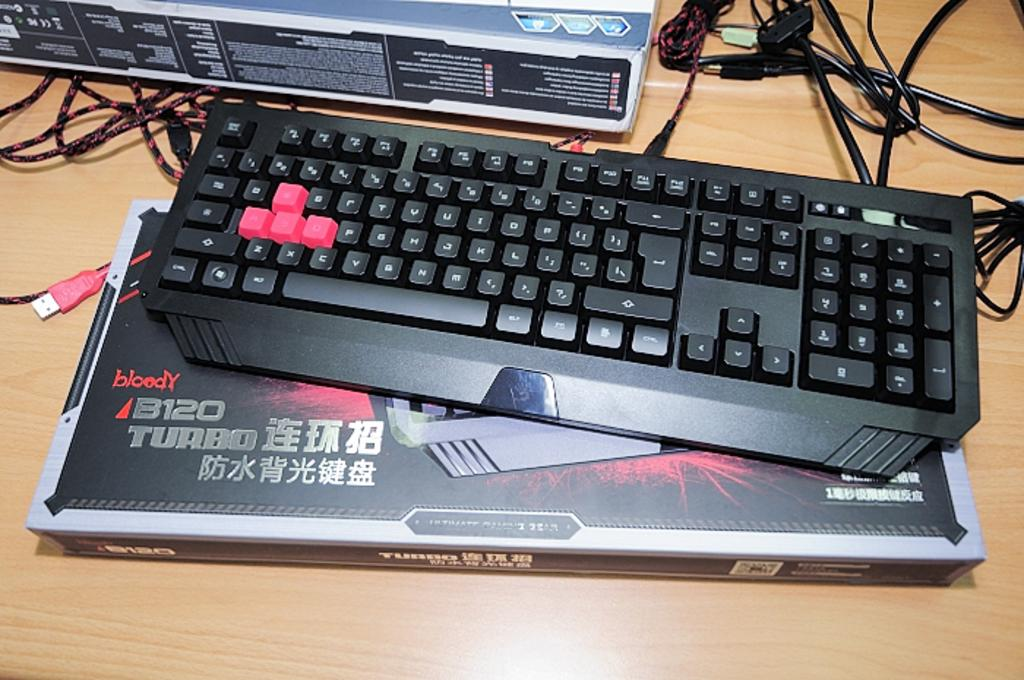<image>
Render a clear and concise summary of the photo. A keyboard is on top of a box which has the word Turbo on it. 